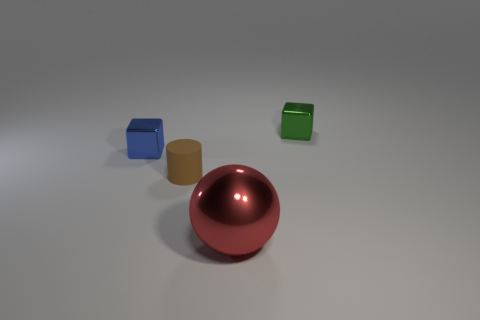What number of shiny things are tiny cylinders or small cubes? 2 